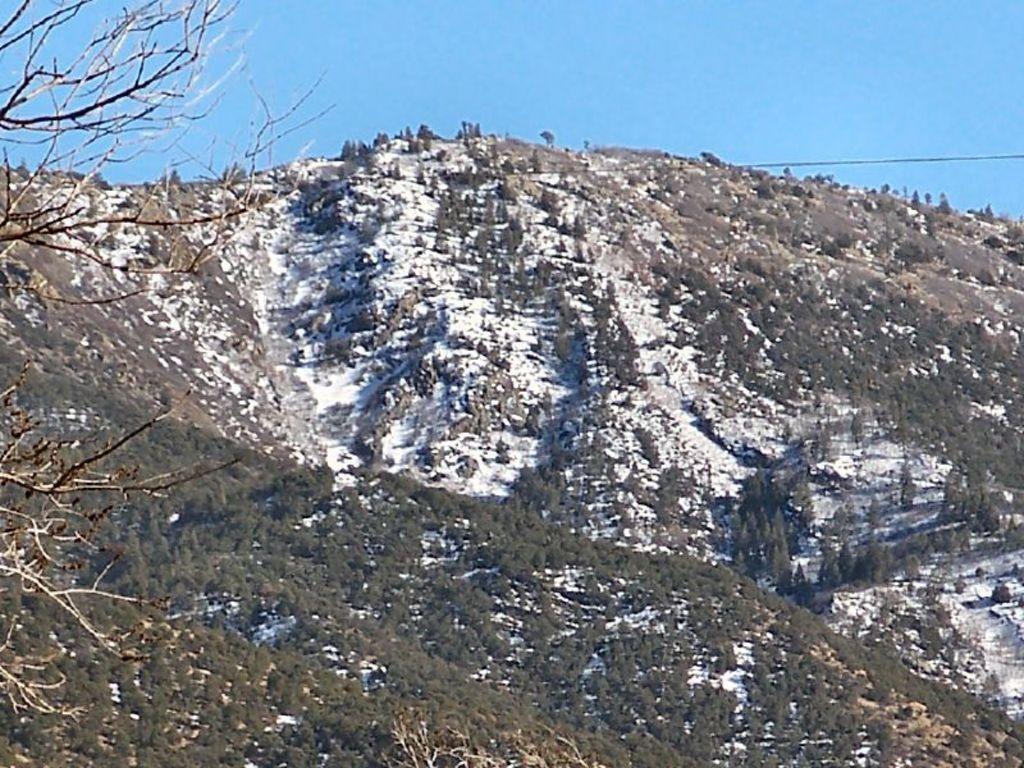Can you describe this image briefly? In the image we can see the mountain, trees, snow and the sky. 